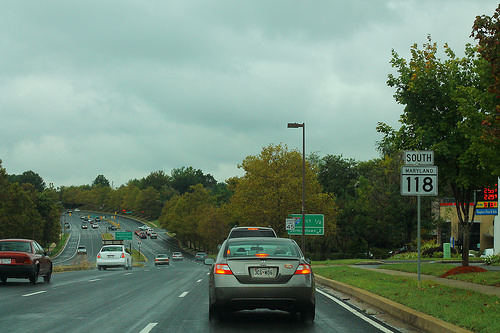<image>
Can you confirm if the car is next to the grass? Yes. The car is positioned adjacent to the grass, located nearby in the same general area. 